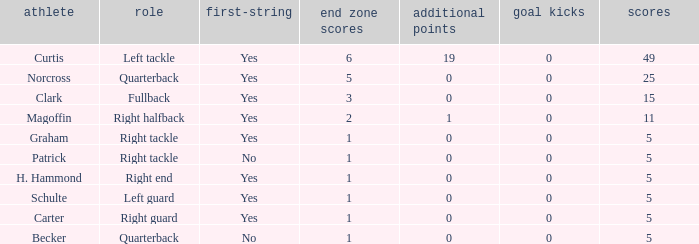Name the most field goals 0.0. Give me the full table as a dictionary. {'header': ['athlete', 'role', 'first-string', 'end zone scores', 'additional points', 'goal kicks', 'scores'], 'rows': [['Curtis', 'Left tackle', 'Yes', '6', '19', '0', '49'], ['Norcross', 'Quarterback', 'Yes', '5', '0', '0', '25'], ['Clark', 'Fullback', 'Yes', '3', '0', '0', '15'], ['Magoffin', 'Right halfback', 'Yes', '2', '1', '0', '11'], ['Graham', 'Right tackle', 'Yes', '1', '0', '0', '5'], ['Patrick', 'Right tackle', 'No', '1', '0', '0', '5'], ['H. Hammond', 'Right end', 'Yes', '1', '0', '0', '5'], ['Schulte', 'Left guard', 'Yes', '1', '0', '0', '5'], ['Carter', 'Right guard', 'Yes', '1', '0', '0', '5'], ['Becker', 'Quarterback', 'No', '1', '0', '0', '5']]} 